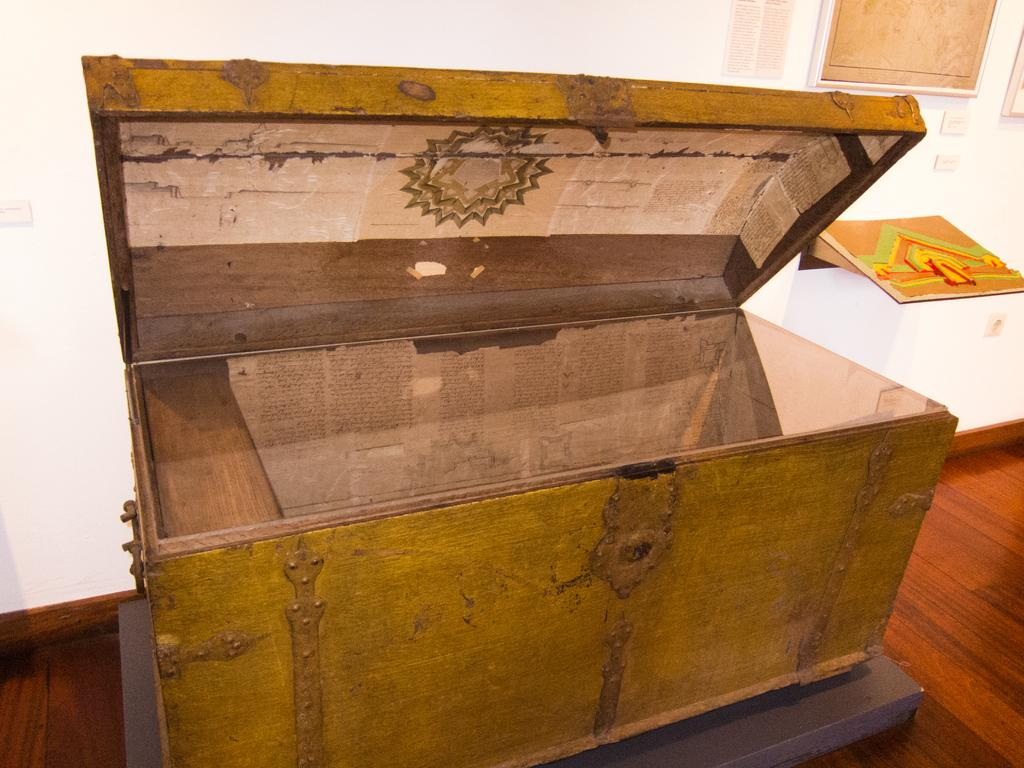What is the main object in the center of the image? There is a box in the center of the image. Where is the box located? The box is placed on a surface. What can be seen on the right side of the image? There are photo frames on the wall and a poster with text on the right side of the image. How does the donkey contribute to the image? There is no donkey present in the image, so it cannot contribute to the image. 